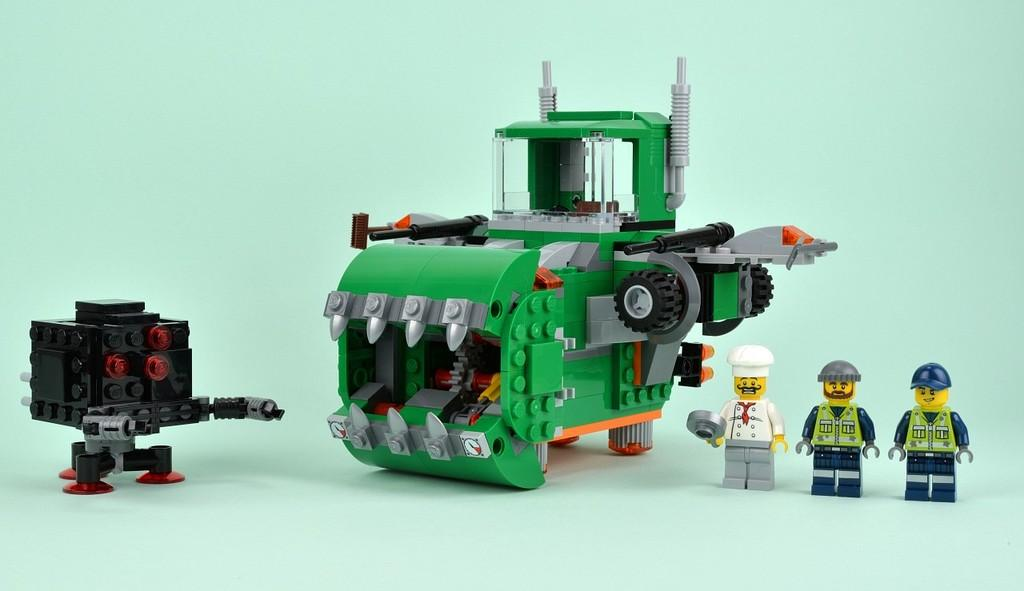What type of toys are featured in the image? There are Lego toys in the image. What types of objects are represented by the Lego toys? The Lego toys include representations of people and machines. Where is the pan located in the image? There is no pan present in the image. Is there a volcano erupting in the image? There is no volcano present in the image. What type of juice is being served in the image? There is no juice present in the image. 